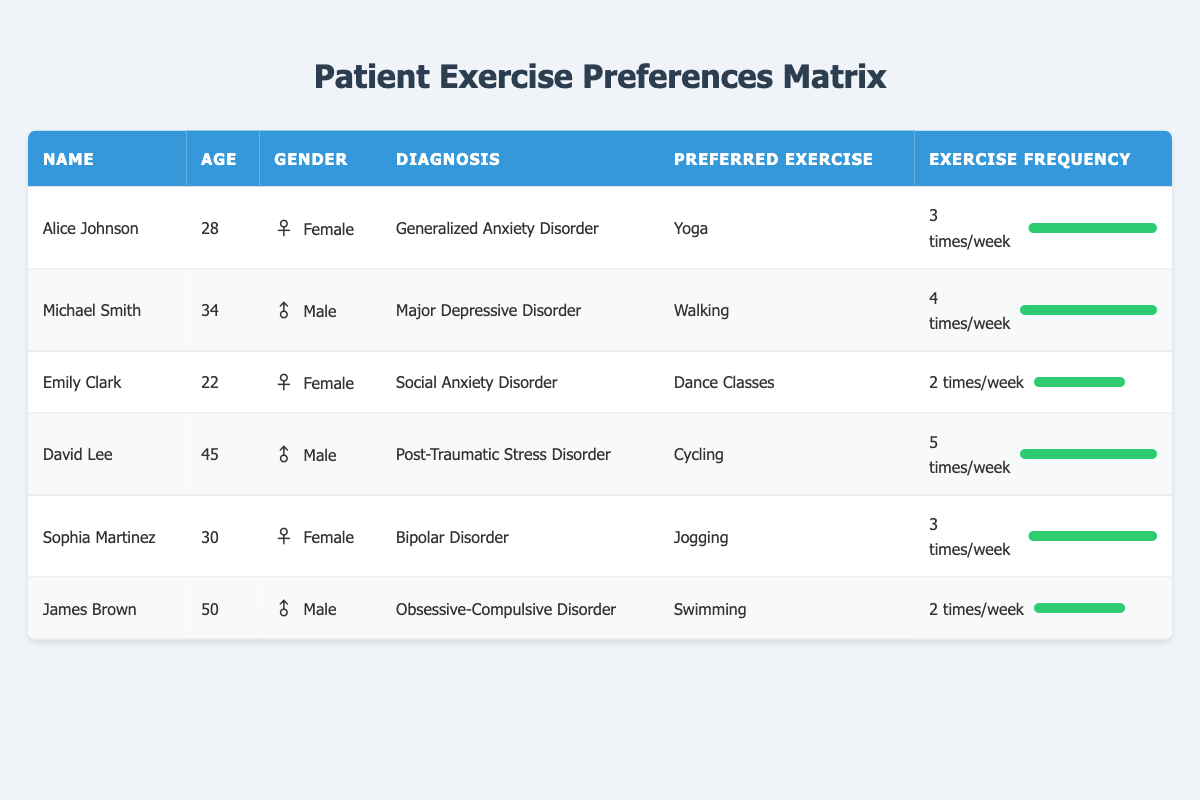What is the preferred exercise of Alice Johnson? Alice Johnson's row in the table shows "Yoga" as her preferred exercise.
Answer: Yoga How many patients prefer walking as their exercise? From the table, Michael Smith is the only patient who has "Walking" listed as his preferred exercise.
Answer: 1 What is the average exercise frequency per week for the patients? The frequencies are 3, 4, 2, 5, 3, and 2. Adding these gives 19, and dividing by the number of patients (6) results in 19/6 = 3.17.
Answer: 3.17 Is David Lee's preferred exercise cycling? The table shows that David Lee has "Cycling" listed as his preferred exercise, confirming the statement is true.
Answer: Yes Which diagnosis has the youngest patient? Emily Clark, at 22 years old, has the youngest age in the table. She has "Social Anxiety Disorder" as her diagnosis.
Answer: Social Anxiety Disorder Which gender has the highest average age among the patients? The ages of male patients are 34, 45, and 50 (average is (34 + 45 + 50) / 3 = 43), while female patients' ages are 28, 22, and 30 (average is (28 + 22 + 30) / 3 = 26.67). Therefore, males have the highest average age.
Answer: Male How many patients exercise 3 times a week? Alice Johnson and Sophia Martinez both exercise 3 times a week, totaling 2 patients.
Answer: 2 Is there a patient who exercises more than 4 times a week? Yes, David Lee exercises 5 times a week, which is more than 4.
Answer: Yes What is the preferred exercise for the oldest patient? The oldest patient is James Brown, who is 50 years old. His preferred exercise is "Swimming."
Answer: Swimming 